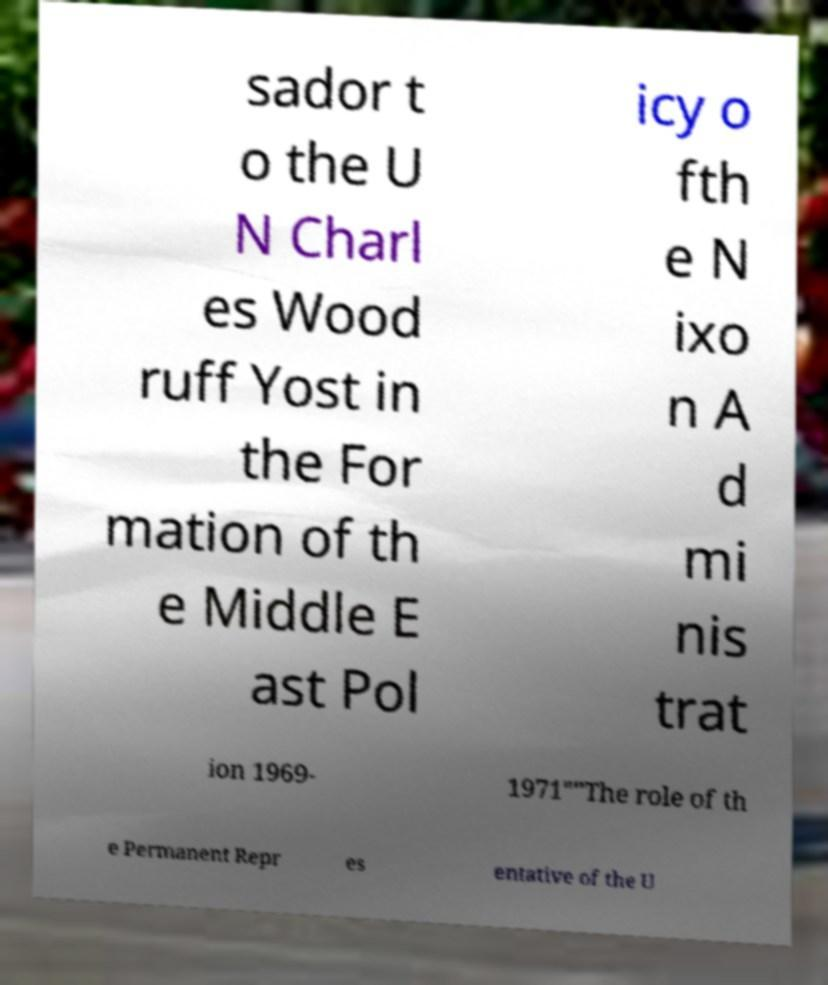Please read and relay the text visible in this image. What does it say? sador t o the U N Charl es Wood ruff Yost in the For mation of th e Middle E ast Pol icy o fth e N ixo n A d mi nis trat ion 1969- 1971""The role of th e Permanent Repr es entative of the U 